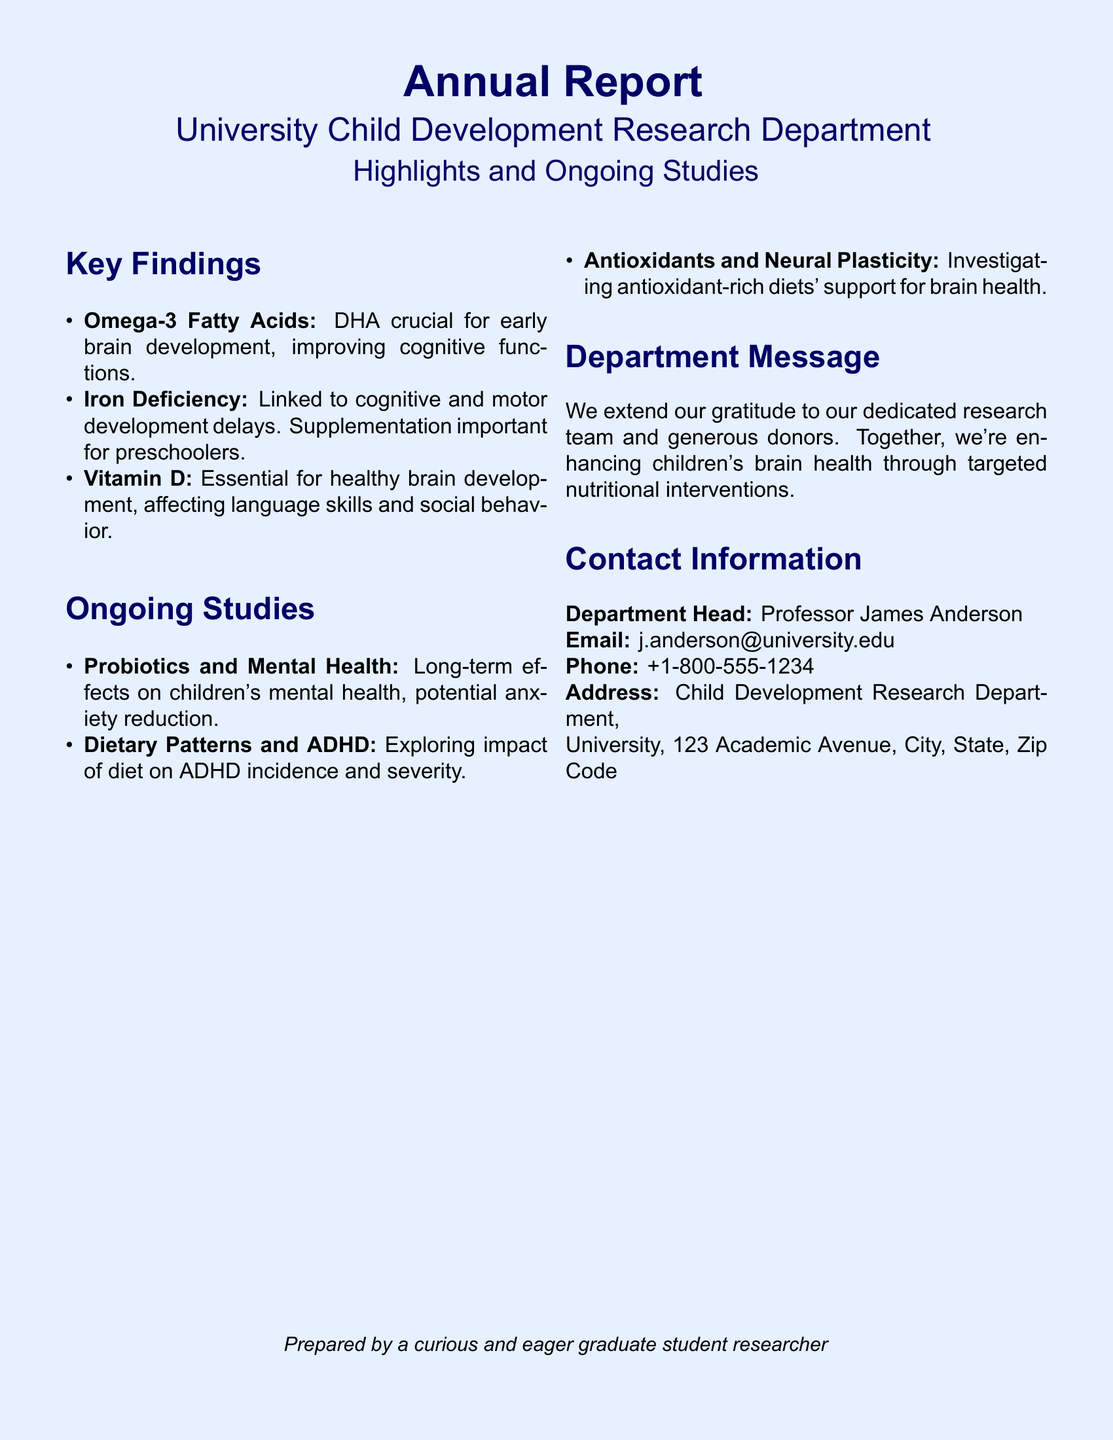What is the title of the report? The title is mentioned at the top of the document, indicating the focus of the content.
Answer: Annual Report Who is the department head? The name of the department head is clearly stated in the contact information section.
Answer: Professor James Anderson What nutrient is linked to cognitive and motor development delays? This information is highlighted in the key findings, specifying a significant nutritional deficiency.
Answer: Iron Deficiency What are probiotics being studied for? The ongoing study section describes the focus of the research involving probiotics.
Answer: Mental Health How many key findings are presented in the report? The number of key findings can be counted from the items listed under the key findings section.
Answer: Three Which vitamin is essential for language skills? The specific vitamin that contributes to language skills is indicated in the key findings section.
Answer: Vitamin D What is being explored in relation to ADHD? The ongoing studies section mentions a specific dietary concern associated with ADHD.
Answer: Dietary Patterns What is the email address of the department head? The email contact is provided in the contact information section, ensuring direct communication.
Answer: j.anderson@university.edu What is the purpose of the department message? The message reflects the gratitude towards the research team and donors for their contributions.
Answer: Enhancing children's brain health 